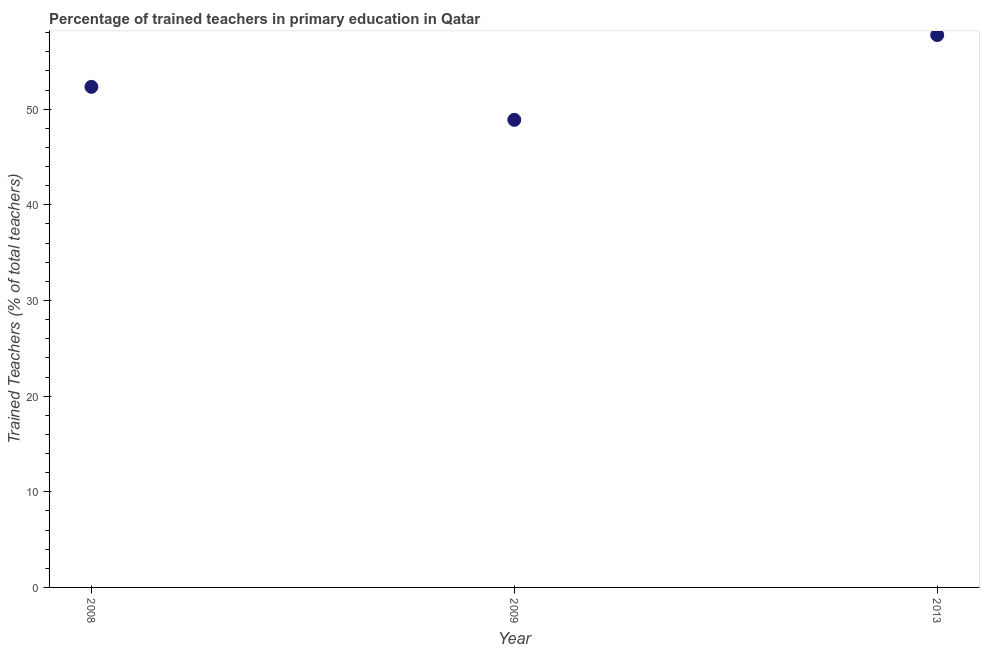What is the percentage of trained teachers in 2008?
Provide a short and direct response. 52.34. Across all years, what is the maximum percentage of trained teachers?
Provide a succinct answer. 57.75. Across all years, what is the minimum percentage of trained teachers?
Your answer should be very brief. 48.89. In which year was the percentage of trained teachers minimum?
Your answer should be very brief. 2009. What is the sum of the percentage of trained teachers?
Your answer should be compact. 158.97. What is the difference between the percentage of trained teachers in 2008 and 2009?
Your response must be concise. 3.45. What is the average percentage of trained teachers per year?
Provide a short and direct response. 52.99. What is the median percentage of trained teachers?
Your answer should be very brief. 52.34. In how many years, is the percentage of trained teachers greater than 12 %?
Ensure brevity in your answer.  3. Do a majority of the years between 2009 and 2008 (inclusive) have percentage of trained teachers greater than 8 %?
Keep it short and to the point. No. What is the ratio of the percentage of trained teachers in 2008 to that in 2009?
Provide a short and direct response. 1.07. Is the percentage of trained teachers in 2009 less than that in 2013?
Provide a short and direct response. Yes. Is the difference between the percentage of trained teachers in 2008 and 2009 greater than the difference between any two years?
Your response must be concise. No. What is the difference between the highest and the second highest percentage of trained teachers?
Your response must be concise. 5.41. Is the sum of the percentage of trained teachers in 2008 and 2009 greater than the maximum percentage of trained teachers across all years?
Offer a very short reply. Yes. What is the difference between the highest and the lowest percentage of trained teachers?
Offer a terse response. 8.86. In how many years, is the percentage of trained teachers greater than the average percentage of trained teachers taken over all years?
Make the answer very short. 1. How many years are there in the graph?
Give a very brief answer. 3. Does the graph contain grids?
Your answer should be compact. No. What is the title of the graph?
Provide a short and direct response. Percentage of trained teachers in primary education in Qatar. What is the label or title of the X-axis?
Provide a short and direct response. Year. What is the label or title of the Y-axis?
Offer a terse response. Trained Teachers (% of total teachers). What is the Trained Teachers (% of total teachers) in 2008?
Keep it short and to the point. 52.34. What is the Trained Teachers (% of total teachers) in 2009?
Your response must be concise. 48.89. What is the Trained Teachers (% of total teachers) in 2013?
Ensure brevity in your answer.  57.75. What is the difference between the Trained Teachers (% of total teachers) in 2008 and 2009?
Provide a short and direct response. 3.45. What is the difference between the Trained Teachers (% of total teachers) in 2008 and 2013?
Make the answer very short. -5.41. What is the difference between the Trained Teachers (% of total teachers) in 2009 and 2013?
Your answer should be very brief. -8.86. What is the ratio of the Trained Teachers (% of total teachers) in 2008 to that in 2009?
Your answer should be compact. 1.07. What is the ratio of the Trained Teachers (% of total teachers) in 2008 to that in 2013?
Offer a very short reply. 0.91. What is the ratio of the Trained Teachers (% of total teachers) in 2009 to that in 2013?
Offer a terse response. 0.85. 